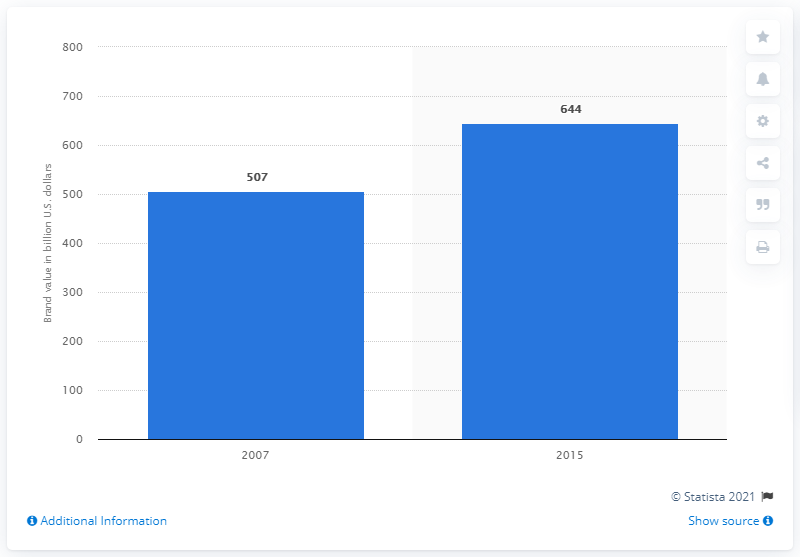List a handful of essential elements in this visual. The brand value of the banking sector in 2015 was estimated to be 644. 